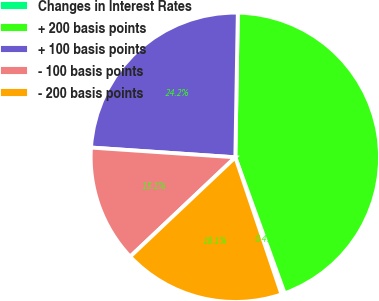Convert chart to OTSL. <chart><loc_0><loc_0><loc_500><loc_500><pie_chart><fcel>Changes in Interest Rates<fcel>+ 200 basis points<fcel>+ 100 basis points<fcel>- 100 basis points<fcel>- 200 basis points<nl><fcel>0.36%<fcel>44.19%<fcel>24.2%<fcel>13.12%<fcel>18.13%<nl></chart> 